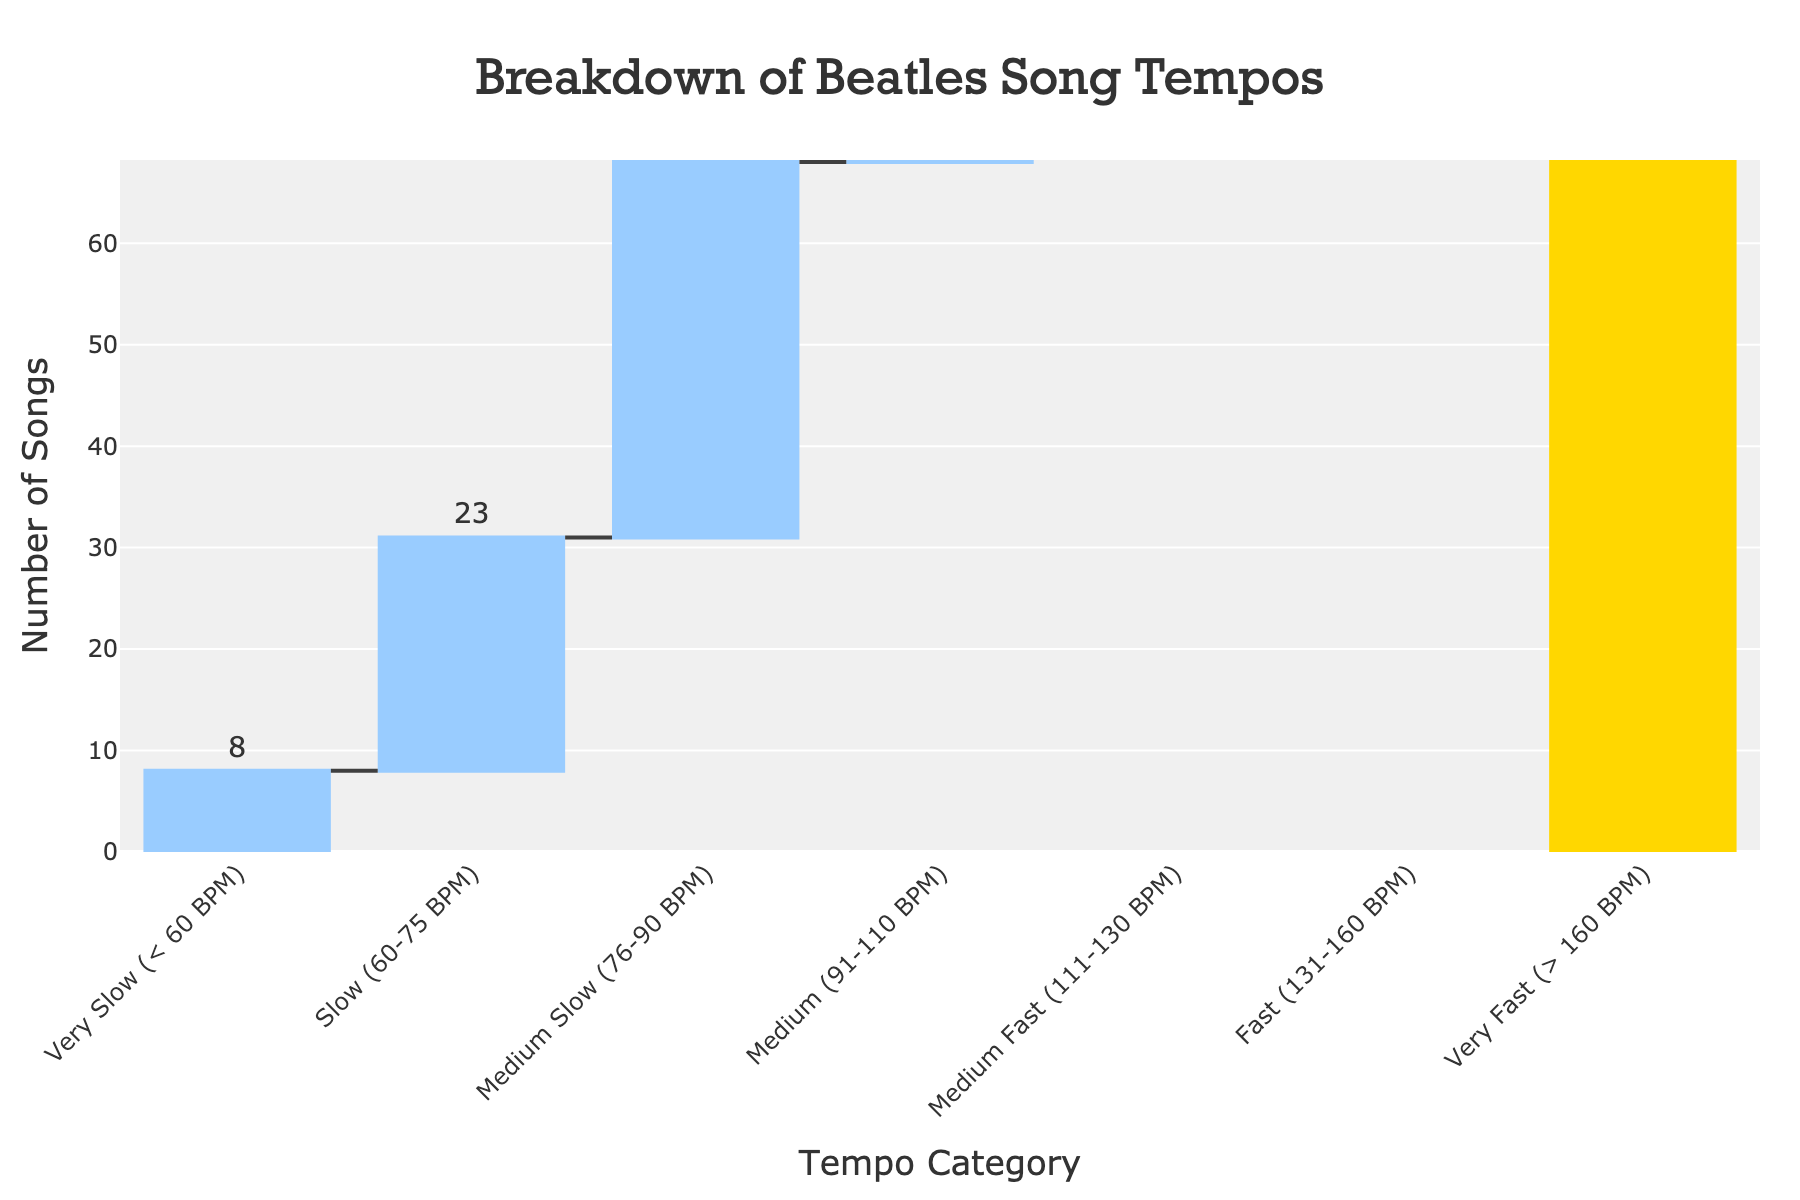What's the title of the chart? The title of the chart is the large text located at the top of the chart. By reading there, we see it says "Breakdown of Beatles Song Tempos".
Answer: Breakdown of Beatles Song Tempos How many categories of tempo are shown in the chart? The x-axis of the chart lists the different tempo categories. By counting them, we can see there are seven categories.
Answer: Seven Which tempo range has the highest number of Beatles songs? By looking at the y-axis values and the bars representing each tempo range, we can see that the category "Medium (91-110 BPM)" has the tallest bar, indicating it has the highest count.
Answer: Medium (91-110 BPM) What is the total number of Beatles songs represented in the chart? The final bar in a waterfall chart usually represents the total sum. By reading the text value on the "total" bar at the end, the count is shown directly.
Answer: 213 How many more songs are there in the "Medium (91-110 BPM)" category compared to the "Very Fast (> 160 BPM)" category? To find the difference, locate the counts for both categories from the chart. The "Medium (91-110 BPM)" category has 62 songs, and the "Very Fast (> 160 BPM)" category has 12 songs. Subtracting 12 from 62 gives 50.
Answer: 50 Which category has fewer songs, "Slow (60-75 BPM)" or "Fast (131-160 BPM)"? Compare the bars and their counts for "Slow (60-75 BPM)" and "Fast (131-160 BPM)" categories. "Slow (60-75 BPM)" has 23 songs while "Fast (131-160 BPM)" has 26 songs.
Answer: Slow (60-75 BPM) What colors are used to indicate increasing and decreasing values? In a waterfall chart, increasing values are usually shown in one color and decreasing values in another. By observing the chart, increasing values are shown in light blue and decreasing values in light red.
Answer: Light blue and light red How many songs are faster than 130 BPM? To find the number of songs faster than 130 BPM, we need to consider the "Fast (131-160 BPM)" and "Very Fast (> 160 BPM)" categories. Summing the counts from both categories (26 + 12) gives 38.
Answer: 38 What's the average number of songs across all the tempo categories? To find the average, add up the counts of all categories and then divide by the number of categories. Sum the counts (8 + 23 + 37 + 62 + 45 + 26 + 12) to get 213. Dividing 213 by 7 categories gives 30.4.
Answer: 30.4 